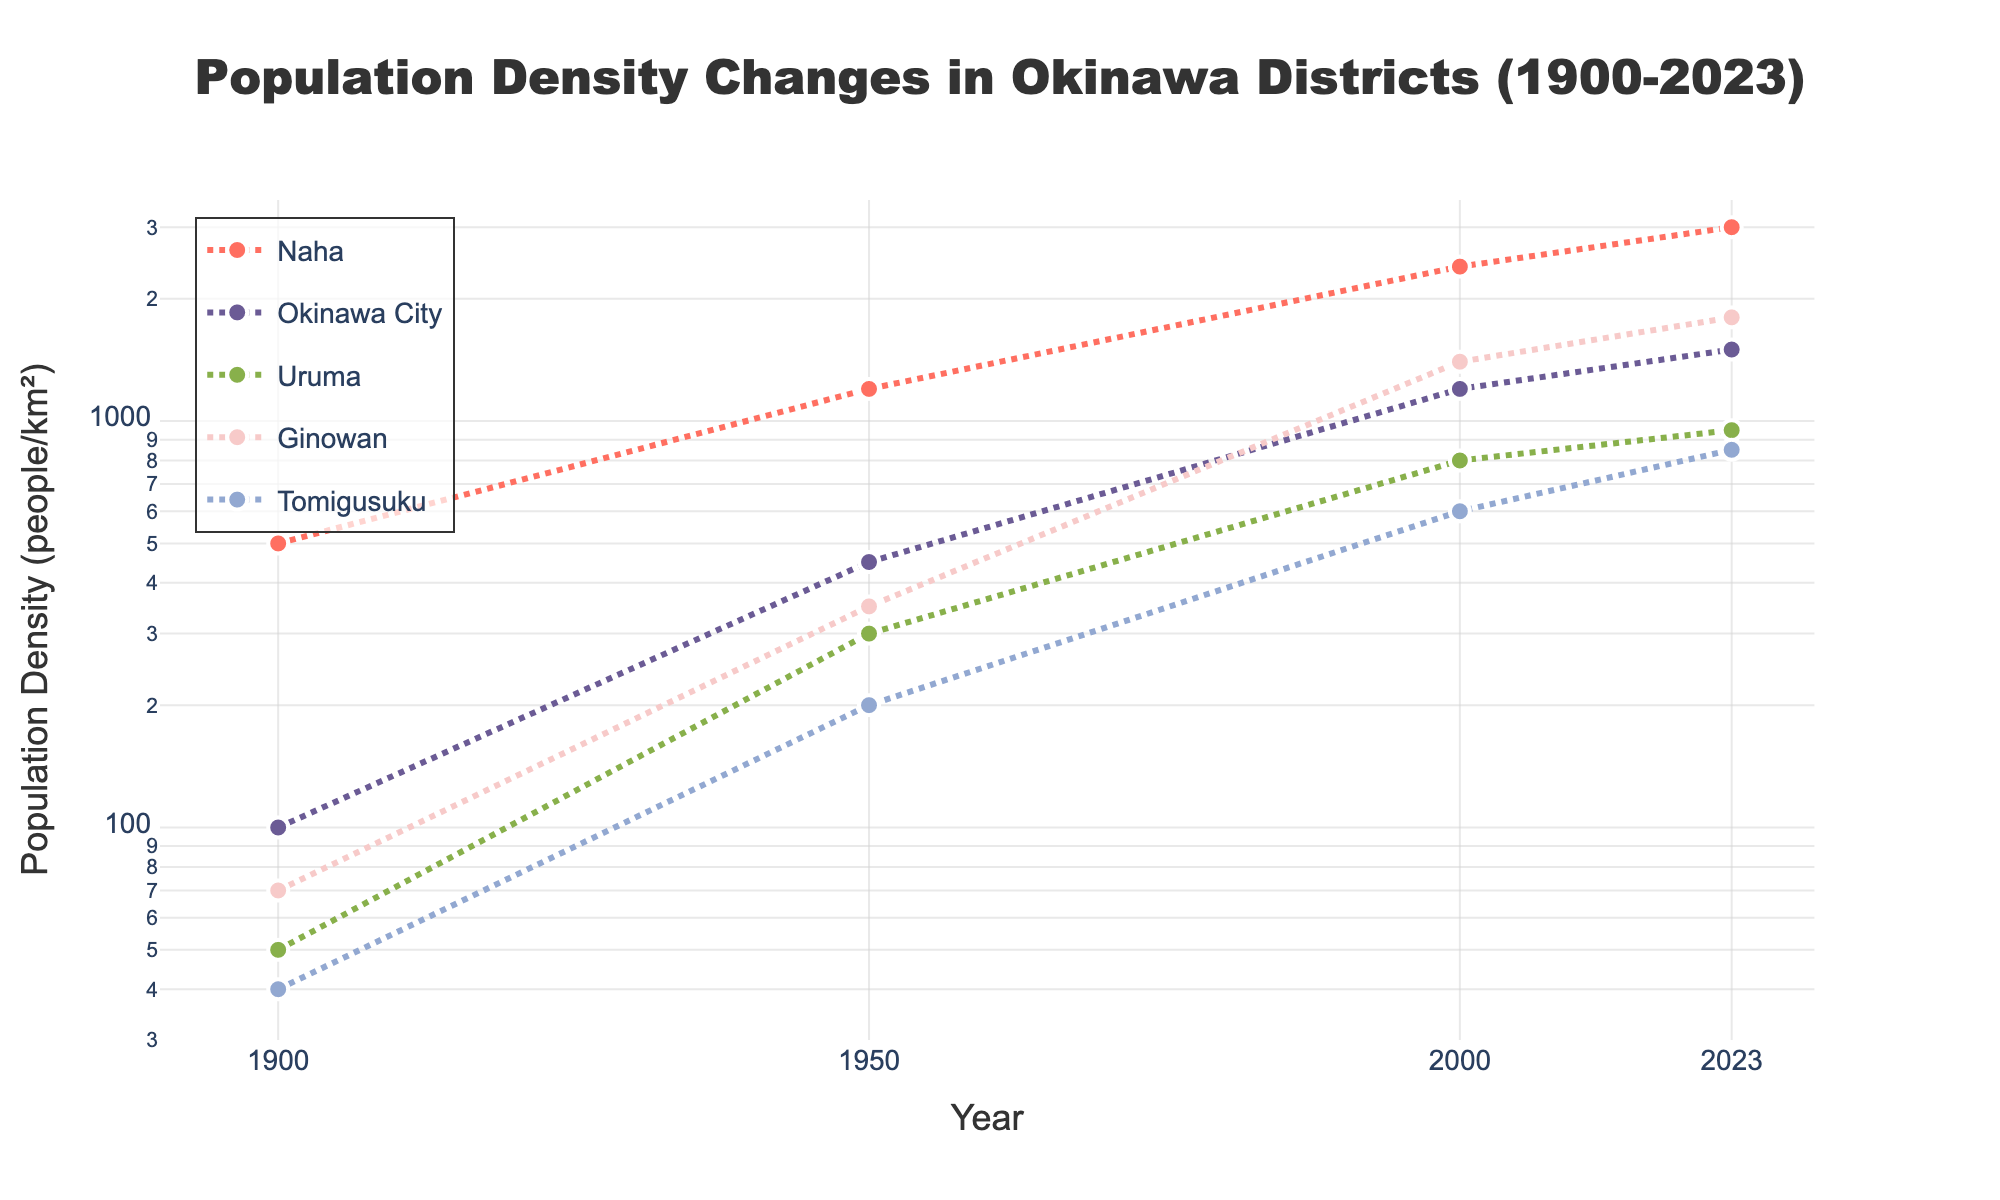Which district had the highest population density in 2023? Look for the highest y-value on the scatter plot for the year 2023. Compare the population densities of all districts at that point.
Answer: Naha What is the trend in population density for Naha from 1900 to 2023? Observe the trend line for Naha. The trend line moves upward indicating an increase in population density over time.
Answer: Increasing Between Okinawa City and Ginowan, which district saw a greater increase in population density from 1900 to 2023? Compare the start and end population densities for both districts. Subtract the 1900 values from the 2023 values for both districts to determine which had a greater increase.
Answer: Ginowan How does the population density in Uruma in 1950 compare to that in Tomigusuku in the same year? Locate the population densities for both Uruma and Tomigusuku in 1950 and compare the two values. Uruma has 300 people/km² and Tomigusuku has 200 people/km².
Answer: Uruma had a higher population density Which district had the least change in population density from 2000 to 2023? Compare the change in population density for each district between 2000 and 2023 by observing the distance between the data points in these years. Uruma changes from 800 to 950, so it has the smallest difference.
Answer: Uruma What is the population density of Naha in 1900 and how does it compare to its population density in 1950? Check the y-values for Naha at the year 1900 and 1950, compare the values directly. Naha had 500 people/km² in 1900 and 1200 people/km² in 1950.
Answer: It increased from 500 to 1200 people/km² What is the average population density of Tomigusuku over all the years represented? Add up all the population density values for Tomigusuku (40 + 200 + 600 + 850) and divide by the number of data points (4). Average = (40 + 200 + 600 + 850) / 4 = 422.5 people/km²
Answer: 422.5 people/km² Which district shows the steepest increase in population density between any two consecutive time points? Examine the slope of the lines connecting the dots for each district. The steepest increase can be seen by looking at the largest vertical jump between two adjacent points.
Answer: Naha between 1900 and 1950 